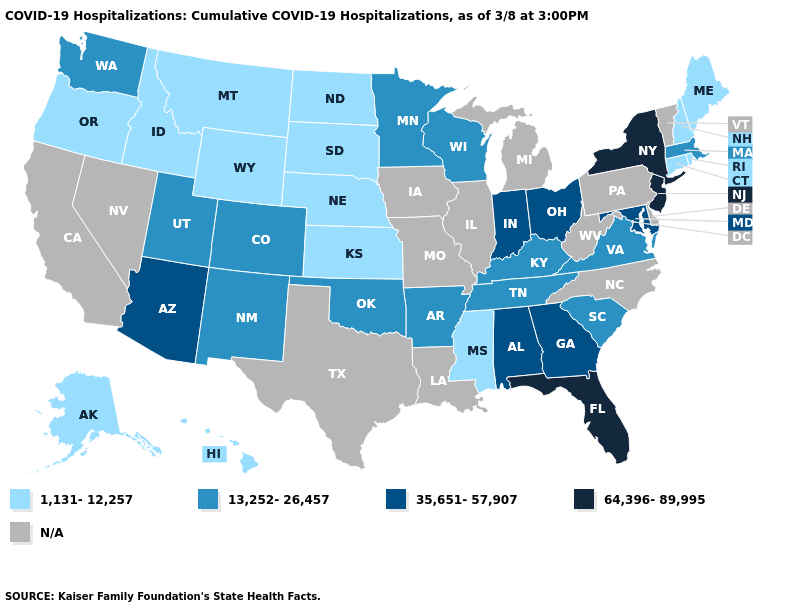Does the map have missing data?
Keep it brief. Yes. Does Connecticut have the highest value in the USA?
Be succinct. No. What is the highest value in states that border Maine?
Keep it brief. 1,131-12,257. Does Rhode Island have the lowest value in the USA?
Short answer required. Yes. Does New York have the highest value in the Northeast?
Answer briefly. Yes. What is the lowest value in the USA?
Keep it brief. 1,131-12,257. Name the states that have a value in the range N/A?
Keep it brief. California, Delaware, Illinois, Iowa, Louisiana, Michigan, Missouri, Nevada, North Carolina, Pennsylvania, Texas, Vermont, West Virginia. What is the lowest value in the MidWest?
Give a very brief answer. 1,131-12,257. What is the value of Alaska?
Keep it brief. 1,131-12,257. Among the states that border Montana , which have the lowest value?
Keep it brief. Idaho, North Dakota, South Dakota, Wyoming. Is the legend a continuous bar?
Answer briefly. No. Name the states that have a value in the range 13,252-26,457?
Short answer required. Arkansas, Colorado, Kentucky, Massachusetts, Minnesota, New Mexico, Oklahoma, South Carolina, Tennessee, Utah, Virginia, Washington, Wisconsin. Name the states that have a value in the range N/A?
Answer briefly. California, Delaware, Illinois, Iowa, Louisiana, Michigan, Missouri, Nevada, North Carolina, Pennsylvania, Texas, Vermont, West Virginia. 